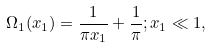Convert formula to latex. <formula><loc_0><loc_0><loc_500><loc_500>\Omega _ { 1 } ( x _ { 1 } ) = \frac { 1 } { \pi x _ { 1 } } + \frac { 1 } { \pi } ; x _ { 1 } \ll 1 ,</formula> 